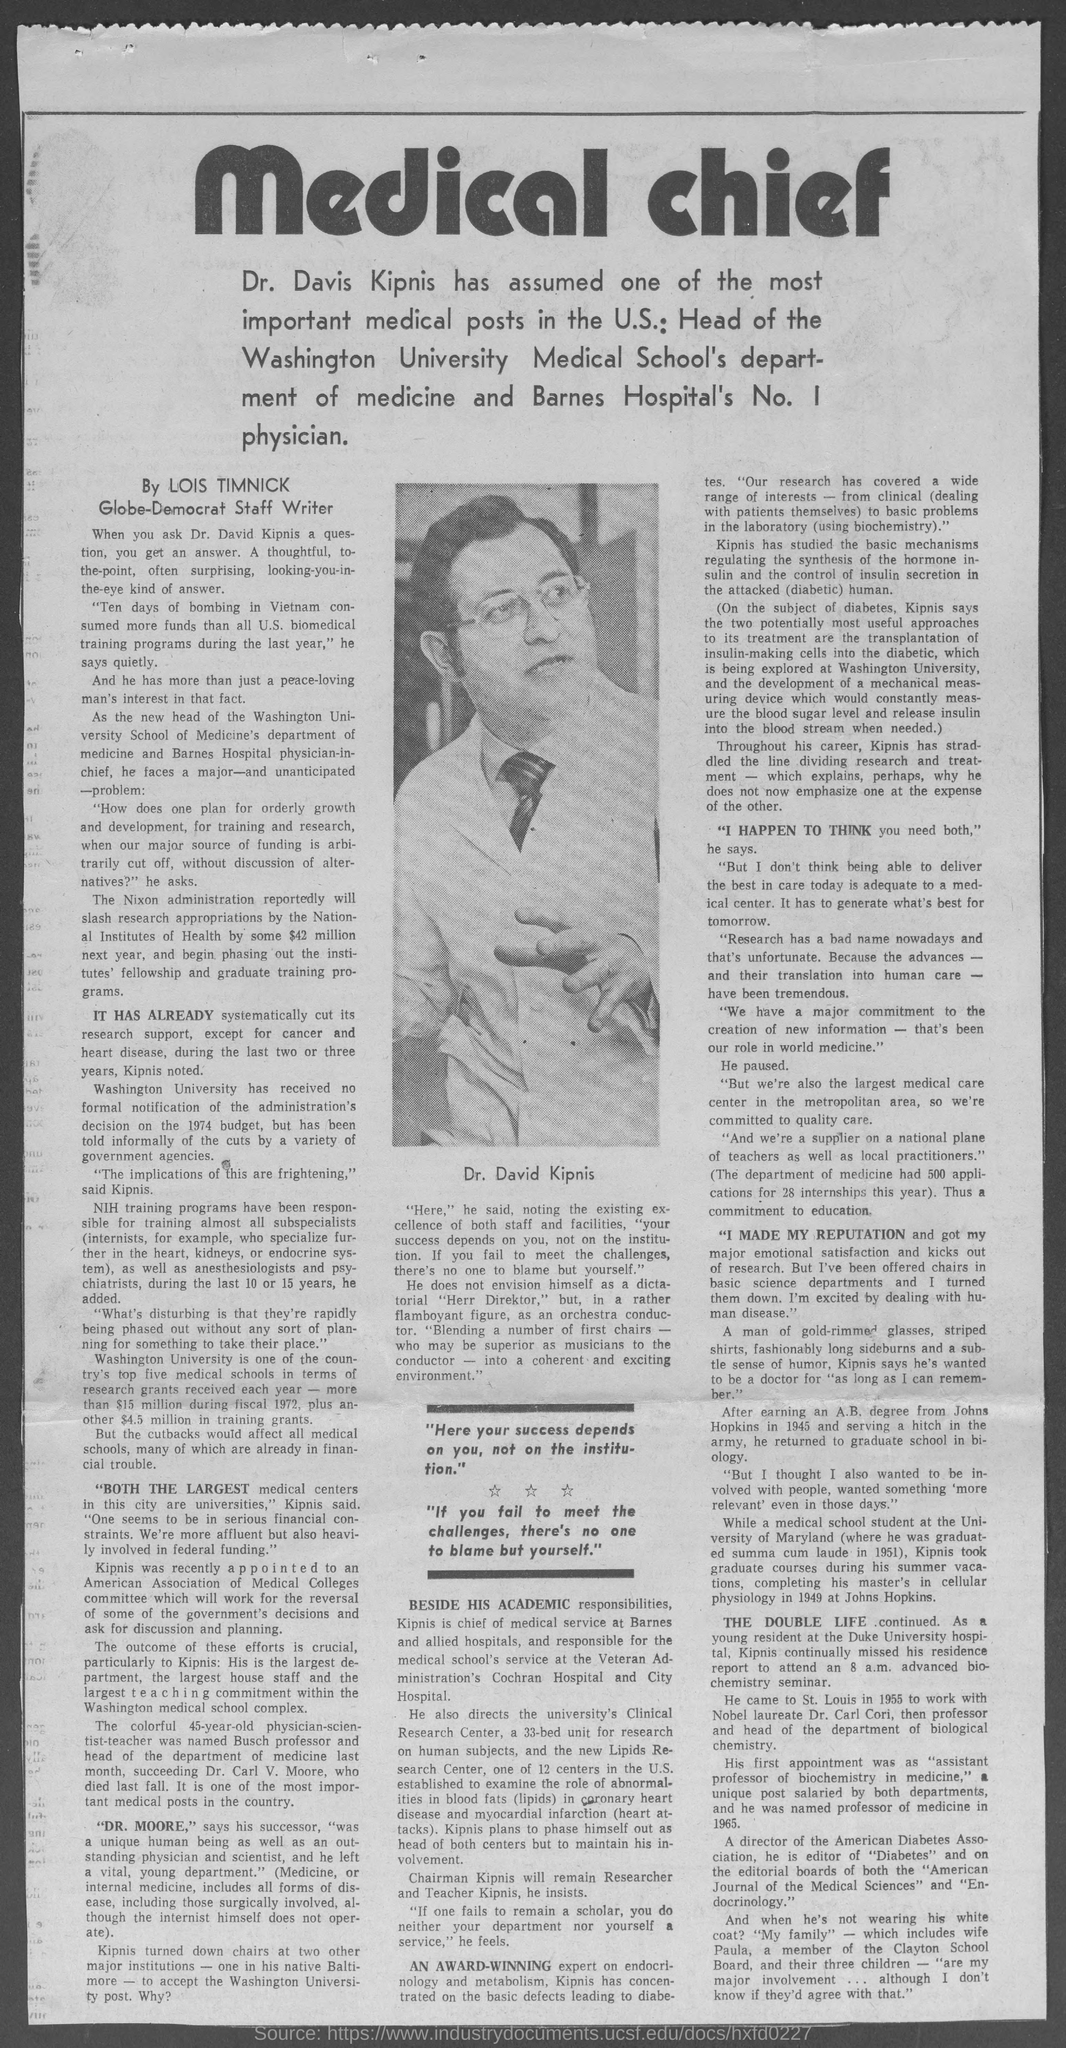Who's picture is shown in the newspaper?
Keep it short and to the point. DR. DAVID KIPNIS. Which university is one of the country's top five medical schools in terms of research grants received each year?
Provide a succinct answer. Washington University. Who quoted " If you fail to meet the challenges, there's no one to blame but yourself."?
Your response must be concise. Dr. David Kipnis. 